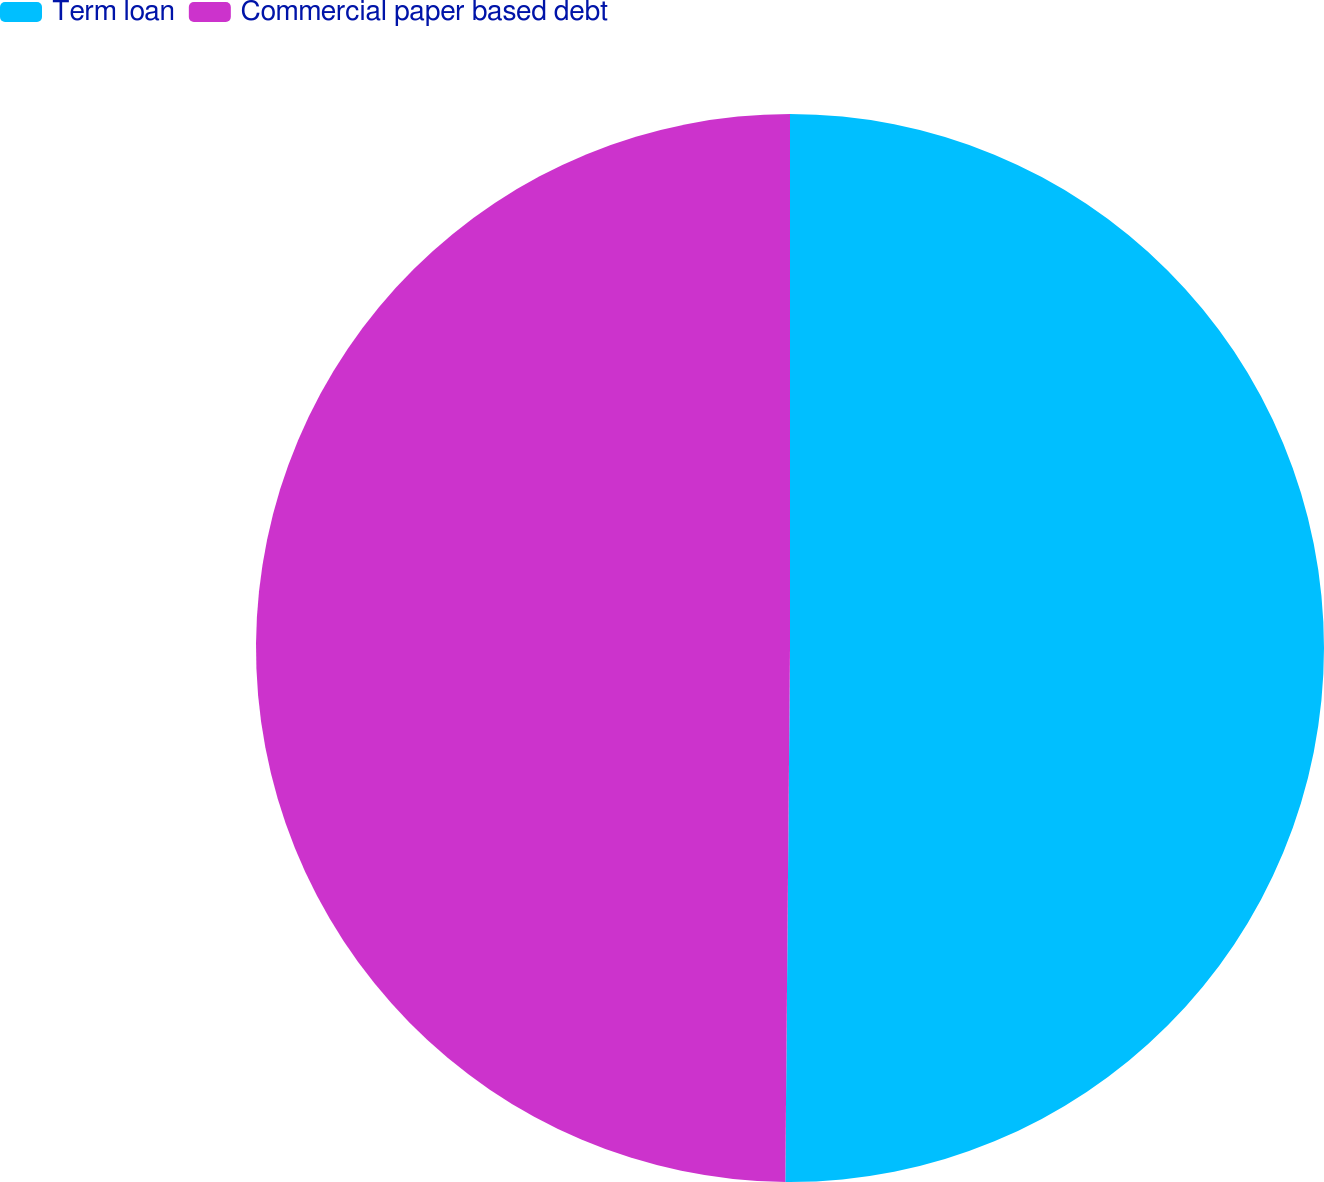<chart> <loc_0><loc_0><loc_500><loc_500><pie_chart><fcel>Term loan<fcel>Commercial paper based debt<nl><fcel>50.14%<fcel>49.86%<nl></chart> 